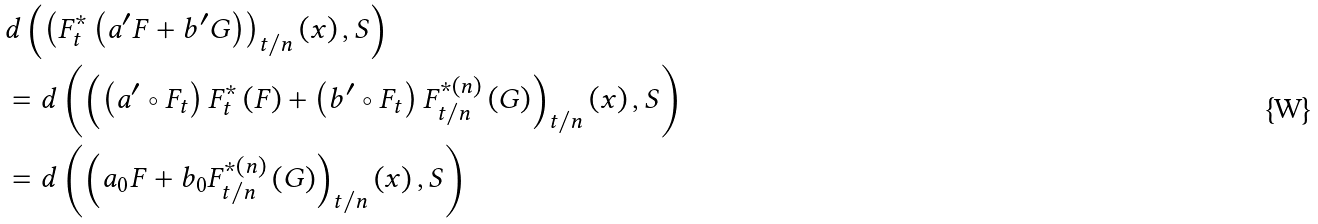<formula> <loc_0><loc_0><loc_500><loc_500>& d \left ( \left ( F _ { t } ^ { \ast } \left ( a ^ { \prime } F + b ^ { \prime } G \right ) \right ) _ { t / n } \left ( x \right ) , S \right ) \\ & = d \left ( \left ( \left ( a ^ { \prime } \circ F _ { t } \right ) F _ { t } ^ { \ast } \left ( F \right ) + \left ( b ^ { \prime } \circ F _ { t } \right ) F _ { t / n } ^ { \ast \left ( n \right ) } \left ( G \right ) \right ) _ { t / n } \left ( x \right ) , S \right ) \\ & = d \left ( \left ( a _ { 0 } F + b _ { 0 } F _ { t / n } ^ { \ast \left ( n \right ) } \left ( G \right ) \right ) _ { t / n } \left ( x \right ) , S \right )</formula> 